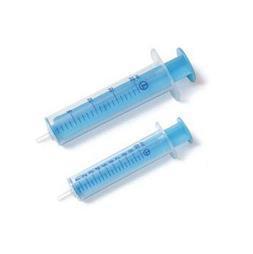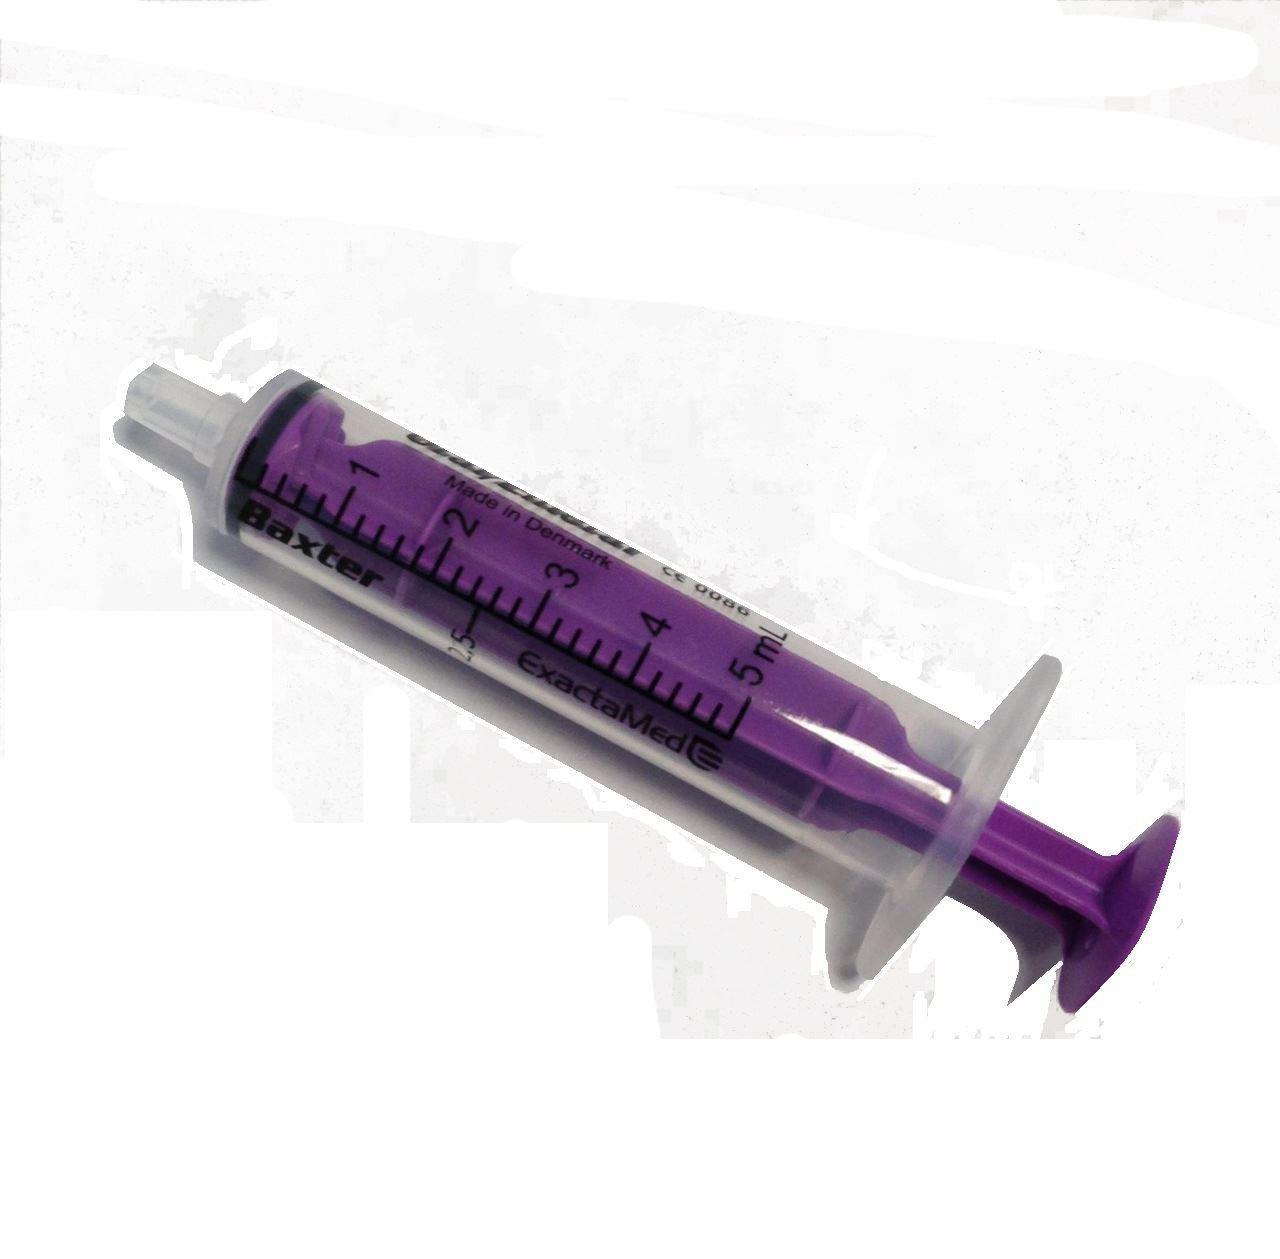The first image is the image on the left, the second image is the image on the right. For the images displayed, is the sentence "The left image is a row of needless syringes pointed downward." factually correct? Answer yes or no. No. The first image is the image on the left, the second image is the image on the right. Given the left and right images, does the statement "The left and right image contains a total of nine syringes." hold true? Answer yes or no. No. 